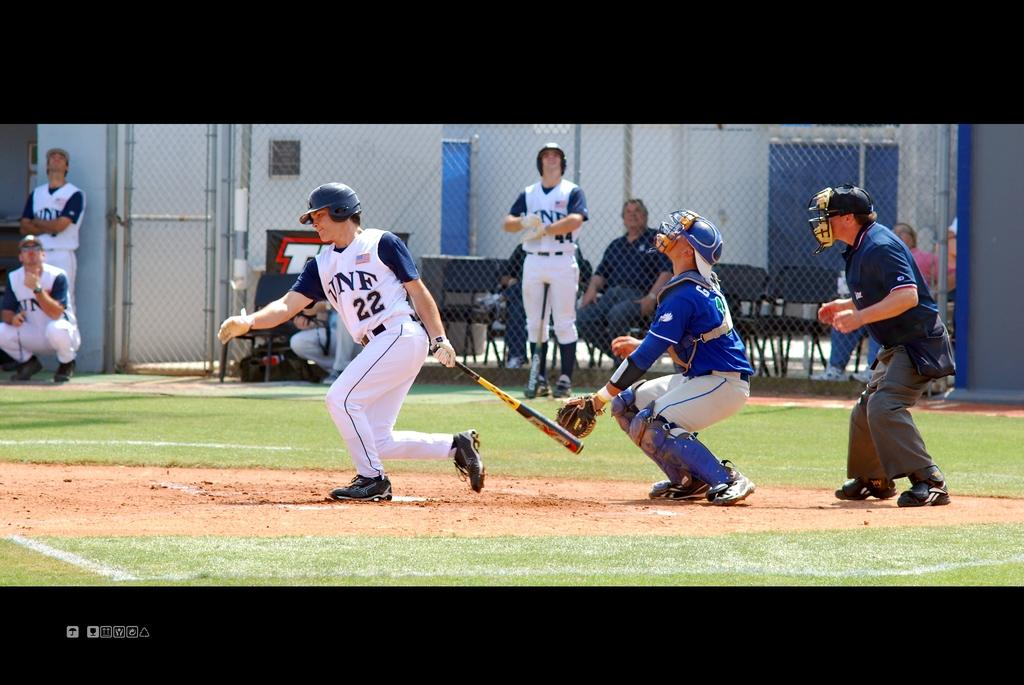<image>
Relay a brief, clear account of the picture shown. player #22 in white in blue with VNF on jersey hits the ball 